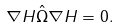<formula> <loc_0><loc_0><loc_500><loc_500>\nabla H \hat { \Omega } \nabla H = 0 .</formula> 